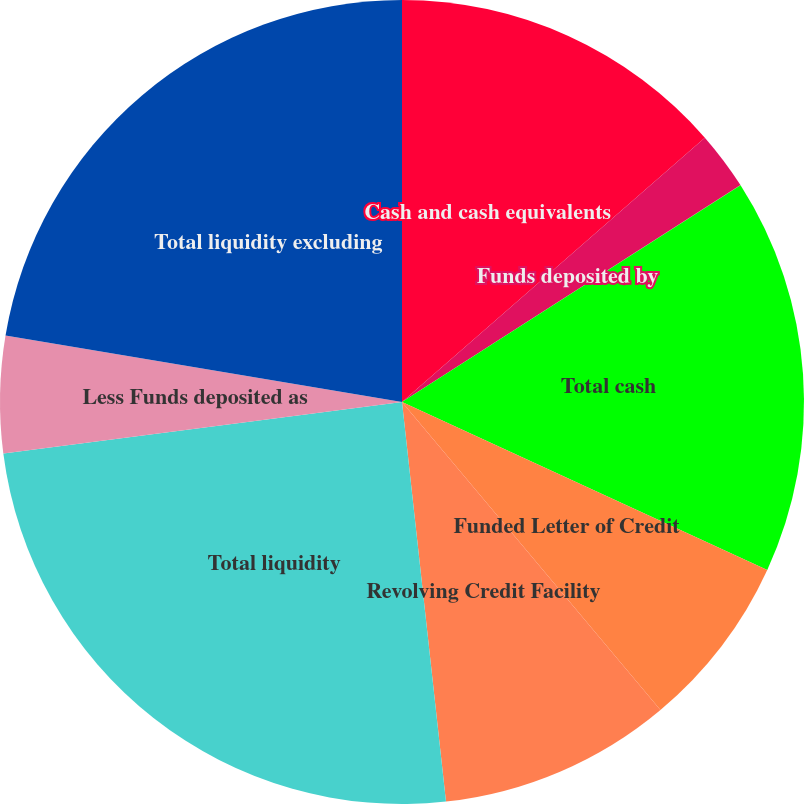Convert chart. <chart><loc_0><loc_0><loc_500><loc_500><pie_chart><fcel>Cash and cash equivalents<fcel>Funds deposited by<fcel>Restricted cash<fcel>Total cash<fcel>Funded Letter of Credit<fcel>Revolving Credit Facility<fcel>Total liquidity<fcel>Less Funds deposited as<fcel>Total liquidity excluding<nl><fcel>13.58%<fcel>2.35%<fcel>0.01%<fcel>15.92%<fcel>7.03%<fcel>9.37%<fcel>24.7%<fcel>4.69%<fcel>22.36%<nl></chart> 